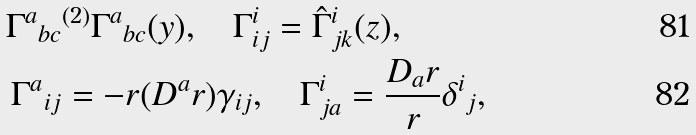<formula> <loc_0><loc_0><loc_500><loc_500>{ \Gamma ^ { a } } _ { b c } & ^ { ( 2 ) } { \Gamma ^ { a } } _ { b c } ( y ) , \quad \Gamma ^ { i } _ { i j } = { \hat { \Gamma } ^ { i } } _ { j k } ( z ) , \\ { \Gamma ^ { a } } _ { i j } & = - r ( D ^ { a } r ) \gamma _ { i j } , \quad \Gamma ^ { i } _ { j a } = \frac { D _ { a } r } { r } { \delta ^ { i } } _ { j } ,</formula> 